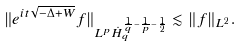<formula> <loc_0><loc_0><loc_500><loc_500>\| e ^ { i t \sqrt { - \Delta + W } } f \| _ { L ^ { p } \dot { H } ^ { \frac { 1 } { q } - \frac { 1 } { p } - \frac { 1 } { 2 } } _ { q } } \lesssim \| f \| _ { L ^ { 2 } } .</formula> 